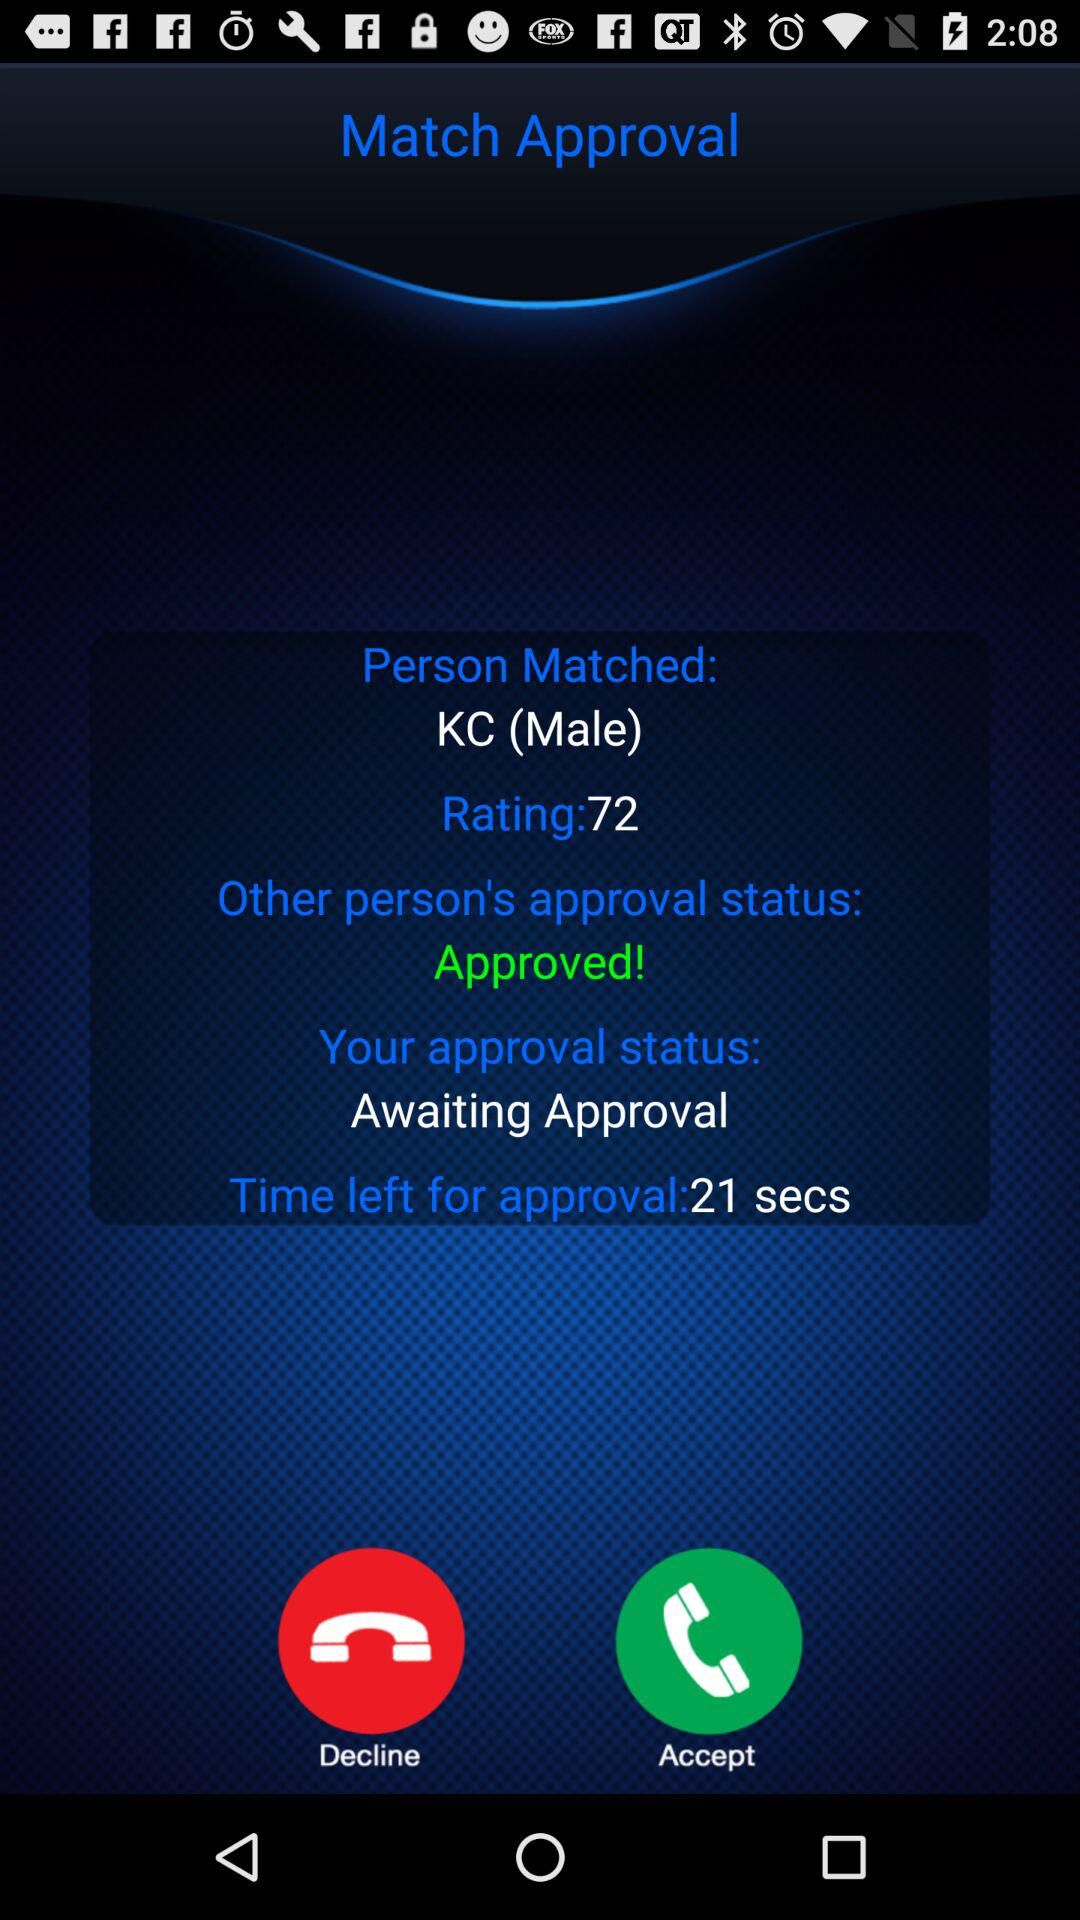What is the gender of the matched person? The gender is male. 